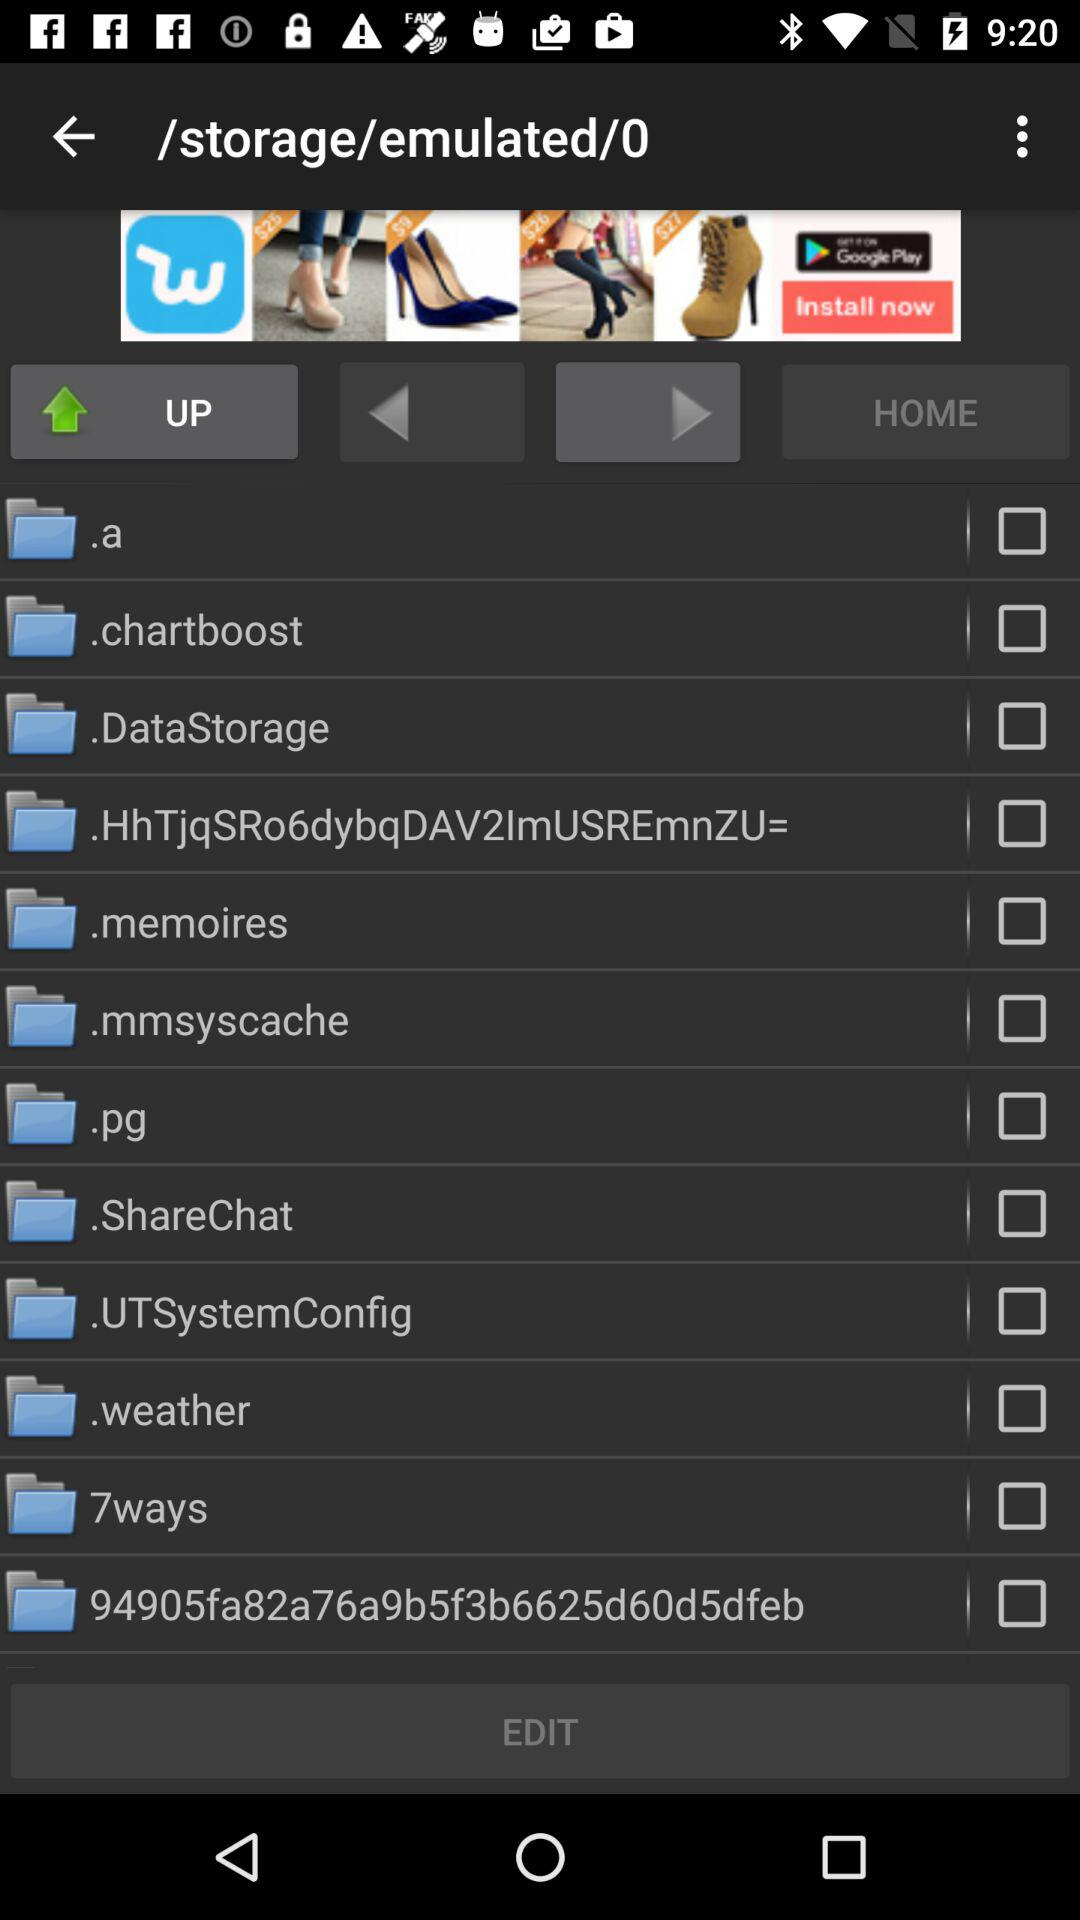What is the current status of the ".pg" folder? The current status is "off". 